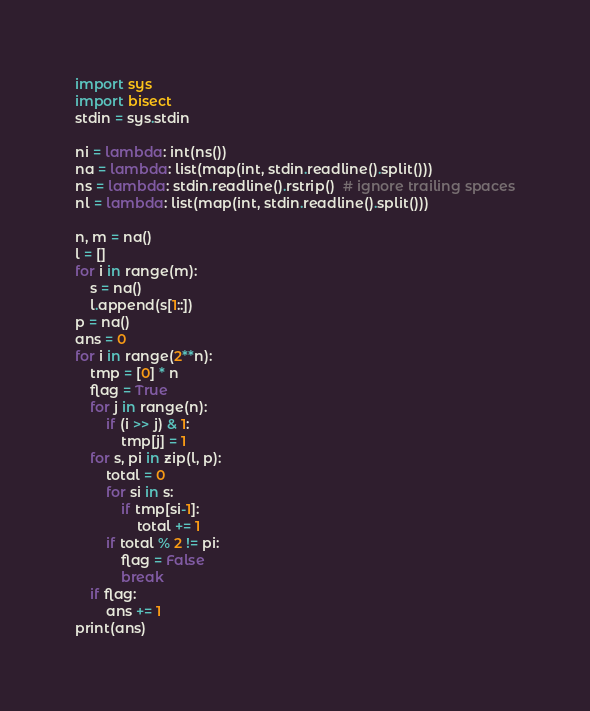<code> <loc_0><loc_0><loc_500><loc_500><_Python_>import sys
import bisect
stdin = sys.stdin

ni = lambda: int(ns())
na = lambda: list(map(int, stdin.readline().split()))
ns = lambda: stdin.readline().rstrip()  # ignore trailing spaces
nl = lambda: list(map(int, stdin.readline().split()))

n, m = na()
l = []
for i in range(m):
    s = na()
    l.append(s[1::])
p = na()
ans = 0
for i in range(2**n):
    tmp = [0] * n
    flag = True
    for j in range(n):
        if (i >> j) & 1:
            tmp[j] = 1
    for s, pi in zip(l, p):
        total = 0
        for si in s:
            if tmp[si-1]:
                total += 1
        if total % 2 != pi:
            flag = False
            break
    if flag:
        ans += 1
print(ans)



</code> 